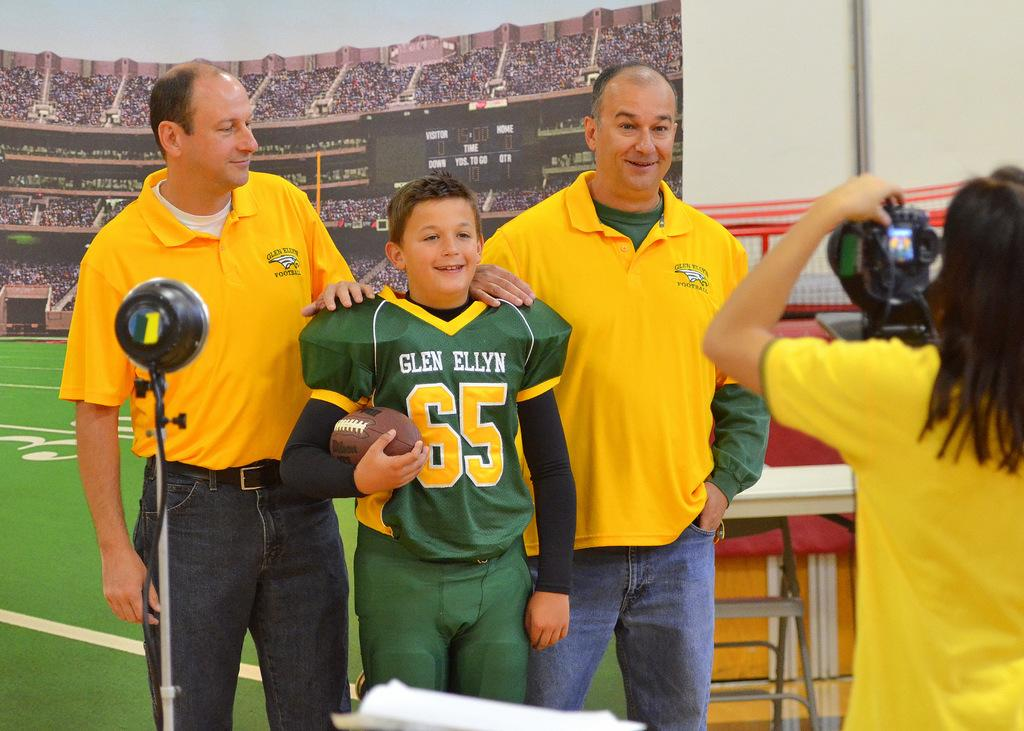<image>
Relay a brief, clear account of the picture shown. A boy wearing a 'Glen Ellyn 65' jersey is standing between two men and posing for a picture. 